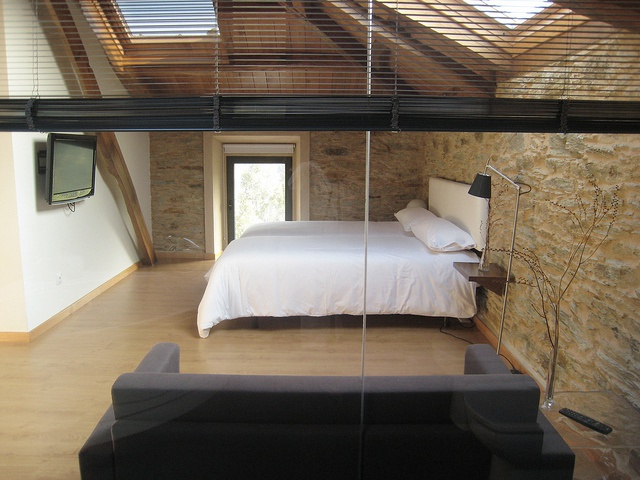Describe the objects in this image and their specific colors. I can see couch in tan, black, and gray tones, bed in tan, lightgray, darkgray, and gray tones, potted plant in tan and gray tones, tv in tan, gray, and black tones, and vase in tan, gray, and black tones in this image. 